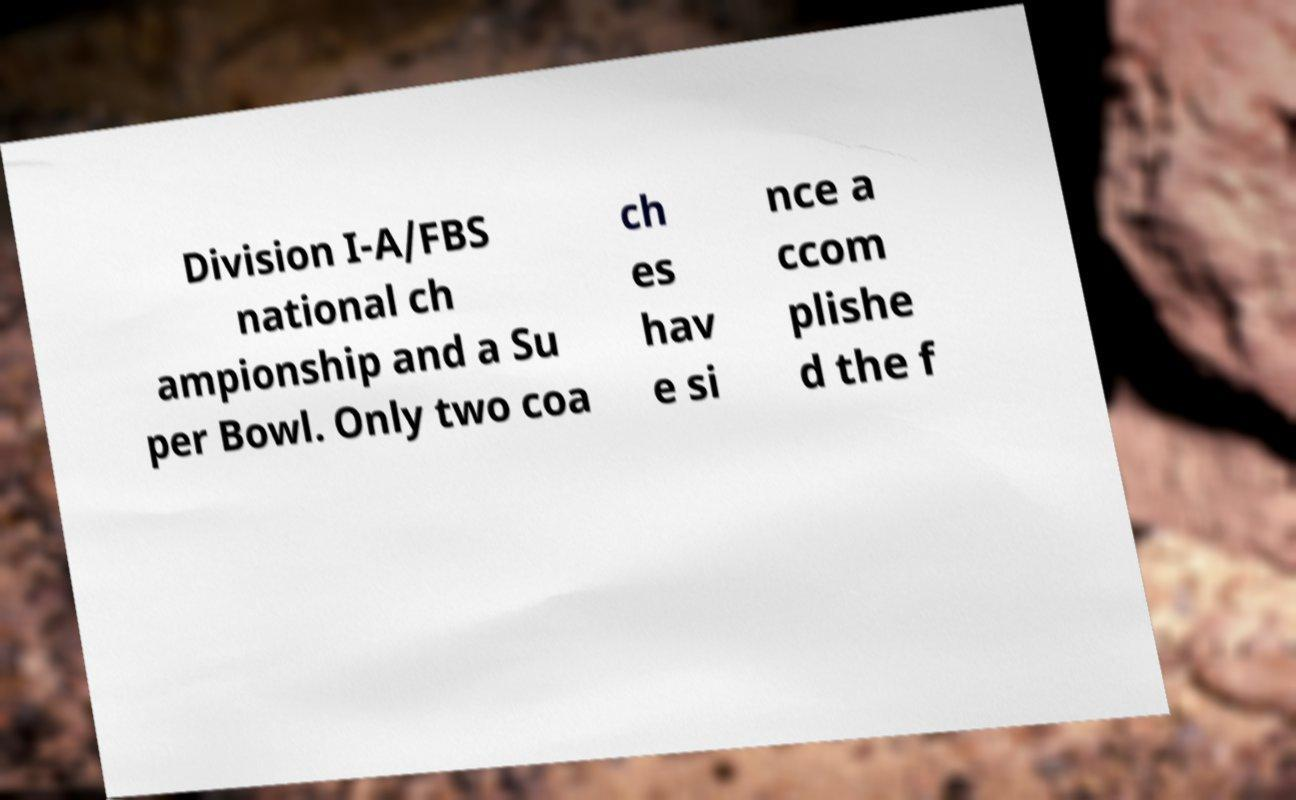Please read and relay the text visible in this image. What does it say? Division I-A/FBS national ch ampionship and a Su per Bowl. Only two coa ch es hav e si nce a ccom plishe d the f 